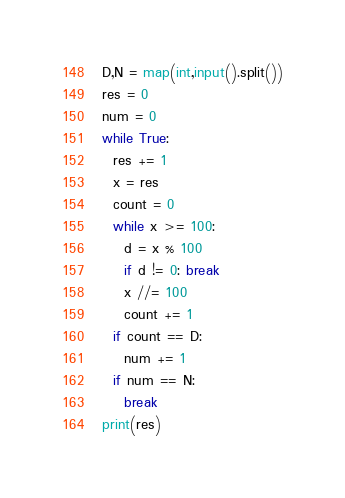Convert code to text. <code><loc_0><loc_0><loc_500><loc_500><_Python_>D,N = map(int,input().split())
res = 0
num = 0
while True:
  res += 1
  x = res
  count = 0
  while x >= 100:
    d = x % 100
    if d != 0: break
    x //= 100
    count += 1
  if count == D:
    num += 1
  if num == N:
    break
print(res)</code> 